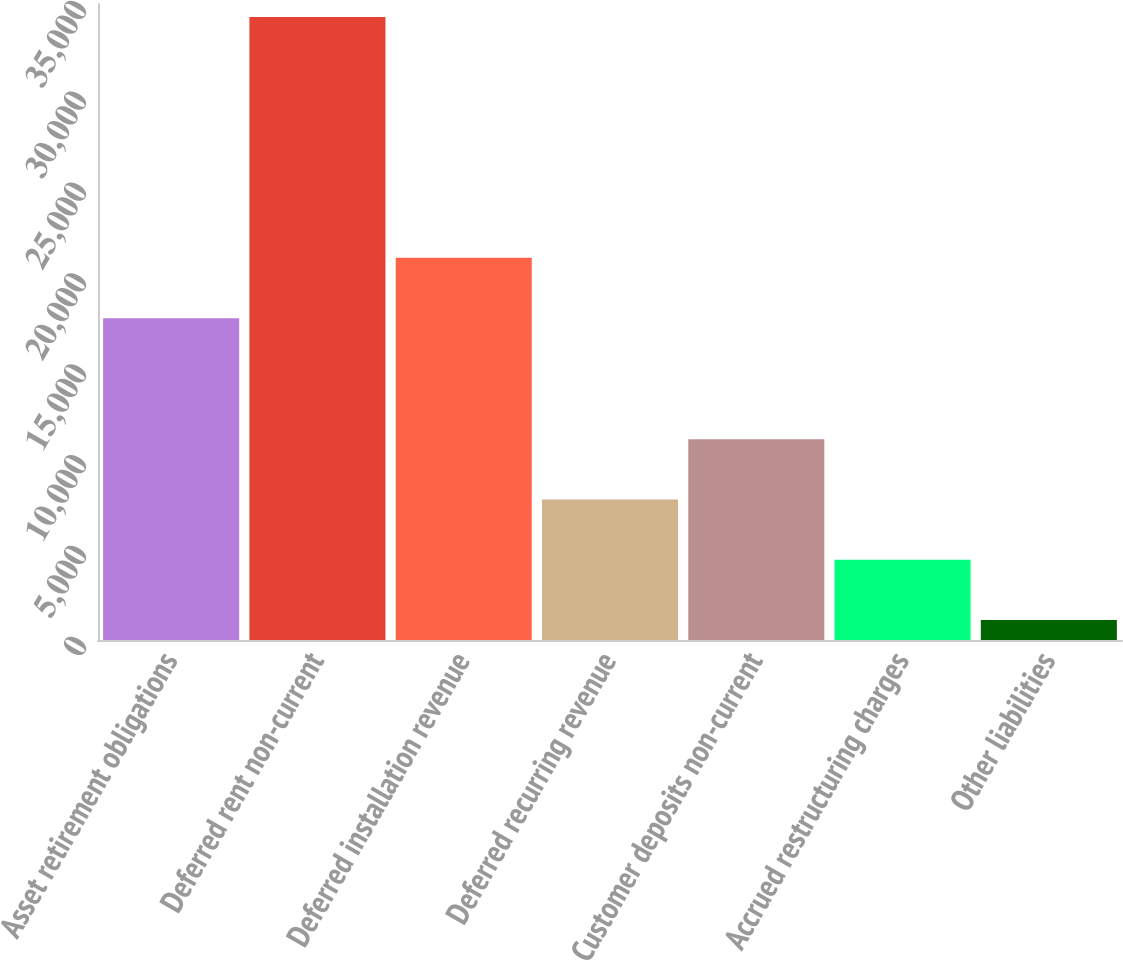Convert chart to OTSL. <chart><loc_0><loc_0><loc_500><loc_500><bar_chart><fcel>Asset retirement obligations<fcel>Deferred rent non-current<fcel>Deferred installation revenue<fcel>Deferred recurring revenue<fcel>Customer deposits non-current<fcel>Accrued restructuring charges<fcel>Other liabilities<nl><fcel>17710<fcel>34288<fcel>21029.3<fcel>7733.6<fcel>11052.9<fcel>4414.3<fcel>1095<nl></chart> 